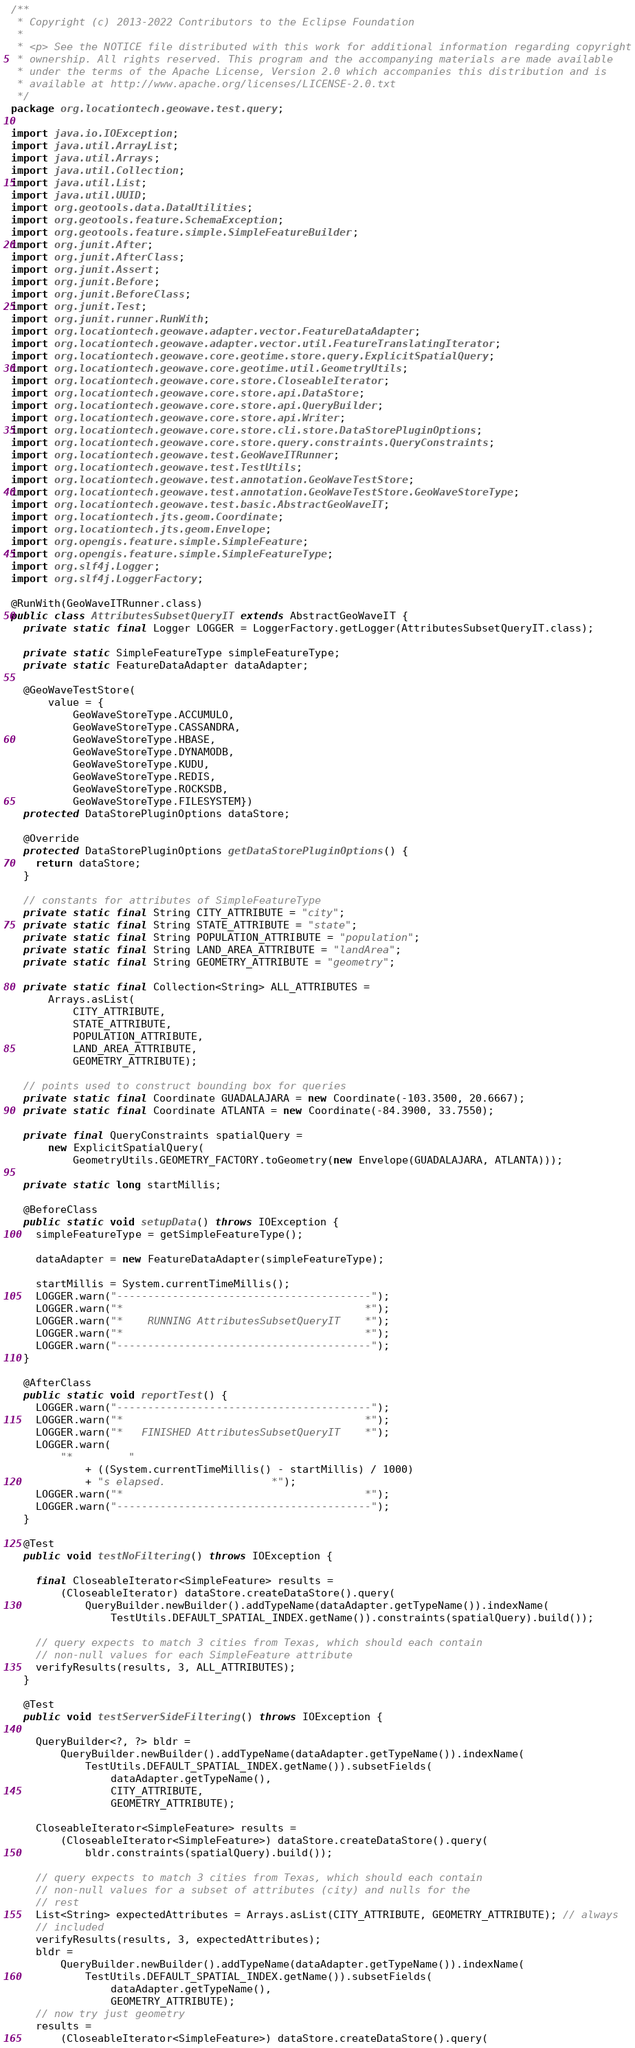<code> <loc_0><loc_0><loc_500><loc_500><_Java_>/**
 * Copyright (c) 2013-2022 Contributors to the Eclipse Foundation
 *
 * <p> See the NOTICE file distributed with this work for additional information regarding copyright
 * ownership. All rights reserved. This program and the accompanying materials are made available
 * under the terms of the Apache License, Version 2.0 which accompanies this distribution and is
 * available at http://www.apache.org/licenses/LICENSE-2.0.txt
 */
package org.locationtech.geowave.test.query;

import java.io.IOException;
import java.util.ArrayList;
import java.util.Arrays;
import java.util.Collection;
import java.util.List;
import java.util.UUID;
import org.geotools.data.DataUtilities;
import org.geotools.feature.SchemaException;
import org.geotools.feature.simple.SimpleFeatureBuilder;
import org.junit.After;
import org.junit.AfterClass;
import org.junit.Assert;
import org.junit.Before;
import org.junit.BeforeClass;
import org.junit.Test;
import org.junit.runner.RunWith;
import org.locationtech.geowave.adapter.vector.FeatureDataAdapter;
import org.locationtech.geowave.adapter.vector.util.FeatureTranslatingIterator;
import org.locationtech.geowave.core.geotime.store.query.ExplicitSpatialQuery;
import org.locationtech.geowave.core.geotime.util.GeometryUtils;
import org.locationtech.geowave.core.store.CloseableIterator;
import org.locationtech.geowave.core.store.api.DataStore;
import org.locationtech.geowave.core.store.api.QueryBuilder;
import org.locationtech.geowave.core.store.api.Writer;
import org.locationtech.geowave.core.store.cli.store.DataStorePluginOptions;
import org.locationtech.geowave.core.store.query.constraints.QueryConstraints;
import org.locationtech.geowave.test.GeoWaveITRunner;
import org.locationtech.geowave.test.TestUtils;
import org.locationtech.geowave.test.annotation.GeoWaveTestStore;
import org.locationtech.geowave.test.annotation.GeoWaveTestStore.GeoWaveStoreType;
import org.locationtech.geowave.test.basic.AbstractGeoWaveIT;
import org.locationtech.jts.geom.Coordinate;
import org.locationtech.jts.geom.Envelope;
import org.opengis.feature.simple.SimpleFeature;
import org.opengis.feature.simple.SimpleFeatureType;
import org.slf4j.Logger;
import org.slf4j.LoggerFactory;

@RunWith(GeoWaveITRunner.class)
public class AttributesSubsetQueryIT extends AbstractGeoWaveIT {
  private static final Logger LOGGER = LoggerFactory.getLogger(AttributesSubsetQueryIT.class);

  private static SimpleFeatureType simpleFeatureType;
  private static FeatureDataAdapter dataAdapter;

  @GeoWaveTestStore(
      value = {
          GeoWaveStoreType.ACCUMULO,
          GeoWaveStoreType.CASSANDRA,
          GeoWaveStoreType.HBASE,
          GeoWaveStoreType.DYNAMODB,
          GeoWaveStoreType.KUDU,
          GeoWaveStoreType.REDIS,
          GeoWaveStoreType.ROCKSDB,
          GeoWaveStoreType.FILESYSTEM})
  protected DataStorePluginOptions dataStore;

  @Override
  protected DataStorePluginOptions getDataStorePluginOptions() {
    return dataStore;
  }

  // constants for attributes of SimpleFeatureType
  private static final String CITY_ATTRIBUTE = "city";
  private static final String STATE_ATTRIBUTE = "state";
  private static final String POPULATION_ATTRIBUTE = "population";
  private static final String LAND_AREA_ATTRIBUTE = "landArea";
  private static final String GEOMETRY_ATTRIBUTE = "geometry";

  private static final Collection<String> ALL_ATTRIBUTES =
      Arrays.asList(
          CITY_ATTRIBUTE,
          STATE_ATTRIBUTE,
          POPULATION_ATTRIBUTE,
          LAND_AREA_ATTRIBUTE,
          GEOMETRY_ATTRIBUTE);

  // points used to construct bounding box for queries
  private static final Coordinate GUADALAJARA = new Coordinate(-103.3500, 20.6667);
  private static final Coordinate ATLANTA = new Coordinate(-84.3900, 33.7550);

  private final QueryConstraints spatialQuery =
      new ExplicitSpatialQuery(
          GeometryUtils.GEOMETRY_FACTORY.toGeometry(new Envelope(GUADALAJARA, ATLANTA)));

  private static long startMillis;

  @BeforeClass
  public static void setupData() throws IOException {
    simpleFeatureType = getSimpleFeatureType();

    dataAdapter = new FeatureDataAdapter(simpleFeatureType);

    startMillis = System.currentTimeMillis();
    LOGGER.warn("-----------------------------------------");
    LOGGER.warn("*                                       *");
    LOGGER.warn("*    RUNNING AttributesSubsetQueryIT    *");
    LOGGER.warn("*                                       *");
    LOGGER.warn("-----------------------------------------");
  }

  @AfterClass
  public static void reportTest() {
    LOGGER.warn("-----------------------------------------");
    LOGGER.warn("*                                       *");
    LOGGER.warn("*   FINISHED AttributesSubsetQueryIT    *");
    LOGGER.warn(
        "*         "
            + ((System.currentTimeMillis() - startMillis) / 1000)
            + "s elapsed.                 *");
    LOGGER.warn("*                                       *");
    LOGGER.warn("-----------------------------------------");
  }

  @Test
  public void testNoFiltering() throws IOException {

    final CloseableIterator<SimpleFeature> results =
        (CloseableIterator) dataStore.createDataStore().query(
            QueryBuilder.newBuilder().addTypeName(dataAdapter.getTypeName()).indexName(
                TestUtils.DEFAULT_SPATIAL_INDEX.getName()).constraints(spatialQuery).build());

    // query expects to match 3 cities from Texas, which should each contain
    // non-null values for each SimpleFeature attribute
    verifyResults(results, 3, ALL_ATTRIBUTES);
  }

  @Test
  public void testServerSideFiltering() throws IOException {

    QueryBuilder<?, ?> bldr =
        QueryBuilder.newBuilder().addTypeName(dataAdapter.getTypeName()).indexName(
            TestUtils.DEFAULT_SPATIAL_INDEX.getName()).subsetFields(
                dataAdapter.getTypeName(),
                CITY_ATTRIBUTE,
                GEOMETRY_ATTRIBUTE);

    CloseableIterator<SimpleFeature> results =
        (CloseableIterator<SimpleFeature>) dataStore.createDataStore().query(
            bldr.constraints(spatialQuery).build());

    // query expects to match 3 cities from Texas, which should each contain
    // non-null values for a subset of attributes (city) and nulls for the
    // rest
    List<String> expectedAttributes = Arrays.asList(CITY_ATTRIBUTE, GEOMETRY_ATTRIBUTE); // always
    // included
    verifyResults(results, 3, expectedAttributes);
    bldr =
        QueryBuilder.newBuilder().addTypeName(dataAdapter.getTypeName()).indexName(
            TestUtils.DEFAULT_SPATIAL_INDEX.getName()).subsetFields(
                dataAdapter.getTypeName(),
                GEOMETRY_ATTRIBUTE);
    // now try just geometry
    results =
        (CloseableIterator<SimpleFeature>) dataStore.createDataStore().query(</code> 